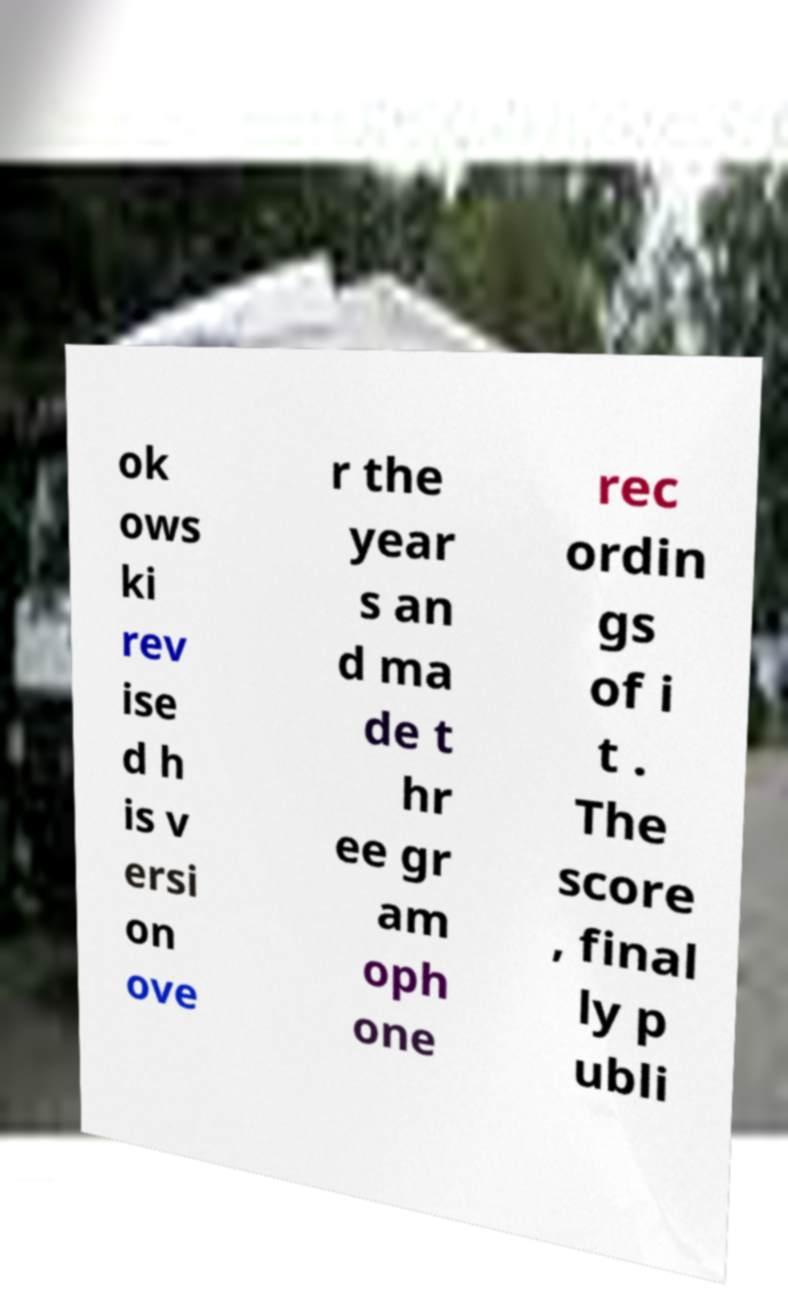Can you read and provide the text displayed in the image?This photo seems to have some interesting text. Can you extract and type it out for me? ok ows ki rev ise d h is v ersi on ove r the year s an d ma de t hr ee gr am oph one rec ordin gs of i t . The score , final ly p ubli 